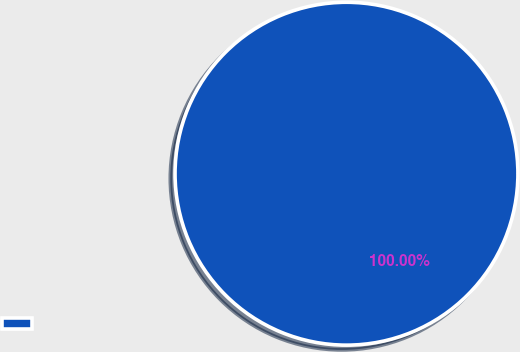Convert chart. <chart><loc_0><loc_0><loc_500><loc_500><pie_chart><ecel><nl><fcel>100.0%<nl></chart> 